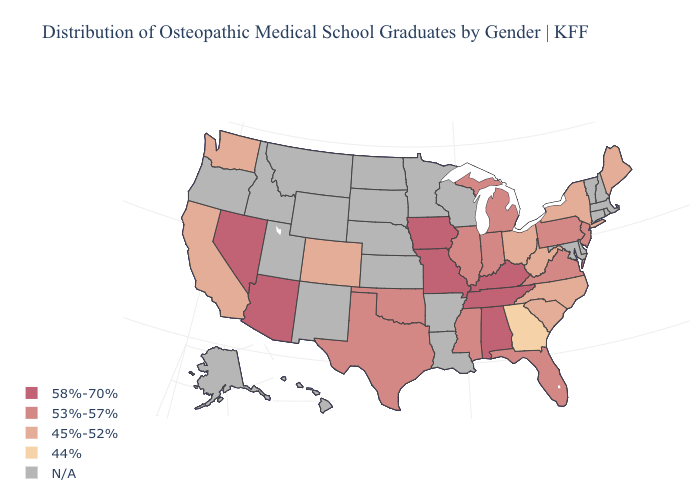Which states have the lowest value in the USA?
Write a very short answer. Georgia. What is the value of North Carolina?
Quick response, please. 45%-52%. What is the lowest value in the Northeast?
Give a very brief answer. 45%-52%. What is the lowest value in the West?
Write a very short answer. 45%-52%. Name the states that have a value in the range 58%-70%?
Write a very short answer. Alabama, Arizona, Iowa, Kentucky, Missouri, Nevada, Tennessee. Name the states that have a value in the range 44%?
Quick response, please. Georgia. What is the value of California?
Answer briefly. 45%-52%. What is the value of Delaware?
Quick response, please. N/A. Among the states that border Georgia , does North Carolina have the lowest value?
Keep it brief. Yes. What is the value of Vermont?
Write a very short answer. N/A. What is the lowest value in the USA?
Write a very short answer. 44%. Is the legend a continuous bar?
Answer briefly. No. Does the first symbol in the legend represent the smallest category?
Quick response, please. No. What is the lowest value in the MidWest?
Keep it brief. 45%-52%. 